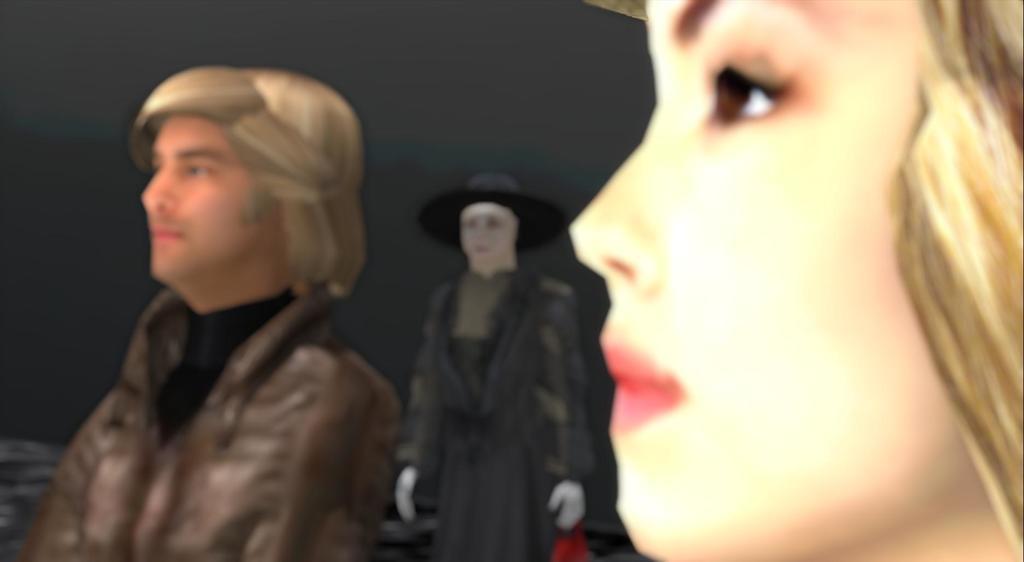In one or two sentences, can you explain what this image depicts? This picture looks like animated image. On the right we can see a woman's face. In the center there is a woman who is wearing black dress. On the left there is a man who is wearing jacket. 